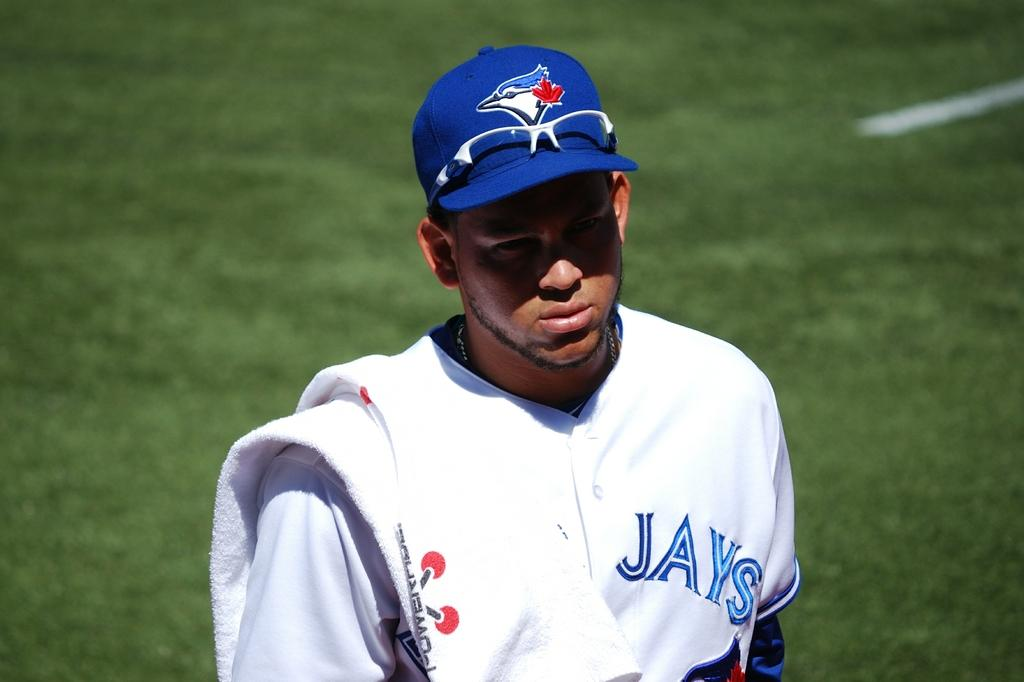<image>
Provide a brief description of the given image. A player for the Toronto Blue Jays has a towel over his shoulder. 